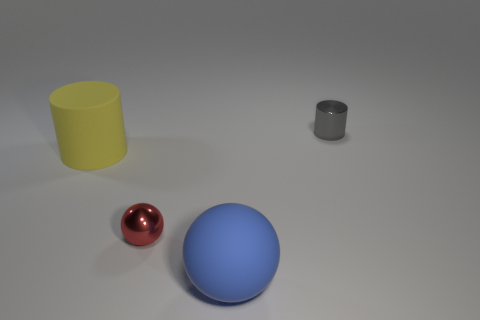Add 3 yellow objects. How many objects exist? 7 Add 1 small balls. How many small balls are left? 2 Add 4 small cylinders. How many small cylinders exist? 5 Subtract 1 red balls. How many objects are left? 3 Subtract all tiny red rubber blocks. Subtract all tiny shiny objects. How many objects are left? 2 